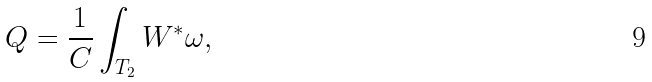<formula> <loc_0><loc_0><loc_500><loc_500>Q = \frac { 1 } { C } \int _ { T _ { 2 } } W ^ { * } \omega ,</formula> 